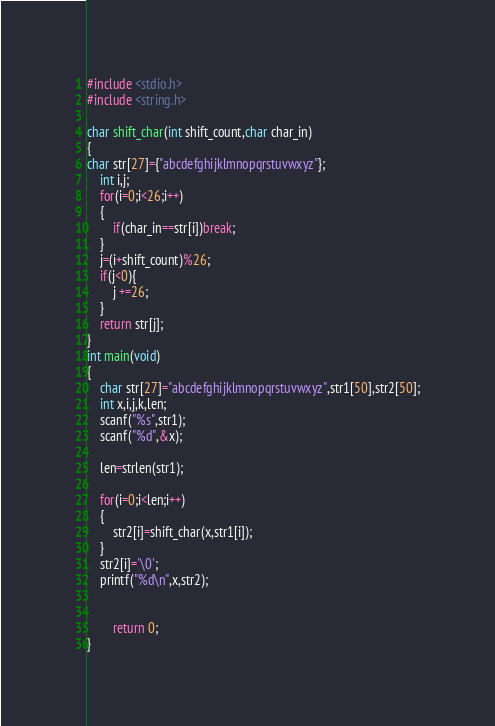<code> <loc_0><loc_0><loc_500><loc_500><_C_>#include <stdio.h>
#include <string.h>

char shift_char(int shift_count,char char_in)
{
char str[27]={"abcdefghijklmnopqrstuvwxyz"};
	int i,j;
	for(i=0;i<26;i++)
	{
		if(char_in==str[i])break;
	}
	j=(i+shift_count)%26;
	if(j<0){
		j +=26;
	}
	return str[j];
}
int main(void)
{
	char str[27]="abcdefghijklmnopqrstuvwxyz",str1[50],str2[50];
	int x,i,j,k,len;
	scanf("%s",str1);
	scanf("%d",&x);
	
	len=strlen(str1);
	
	for(i=0;i<len;i++)
	{
		str2[i]=shift_char(x,str1[i]);
	}
	str2[i]='\0';
	printf("%d\n",x,str2);
	
	
		return 0;
}</code> 